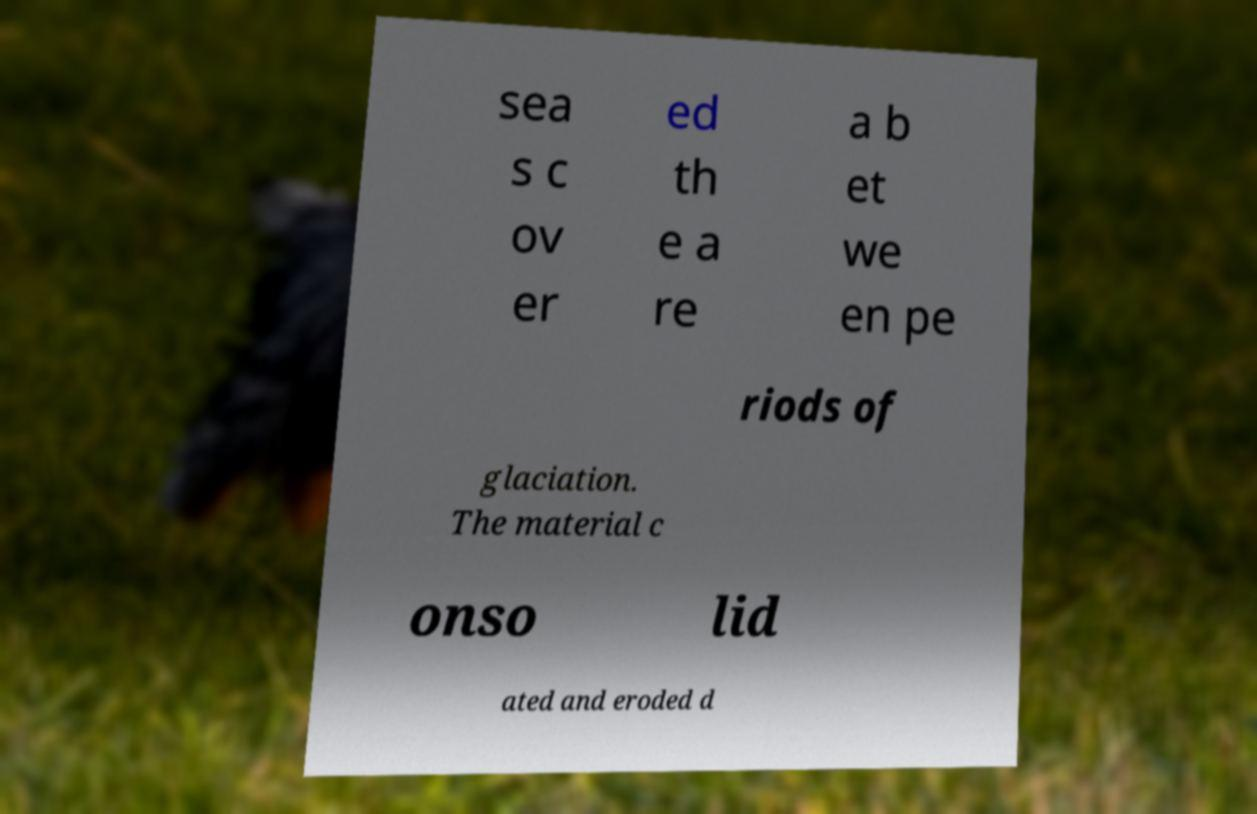There's text embedded in this image that I need extracted. Can you transcribe it verbatim? sea s c ov er ed th e a re a b et we en pe riods of glaciation. The material c onso lid ated and eroded d 